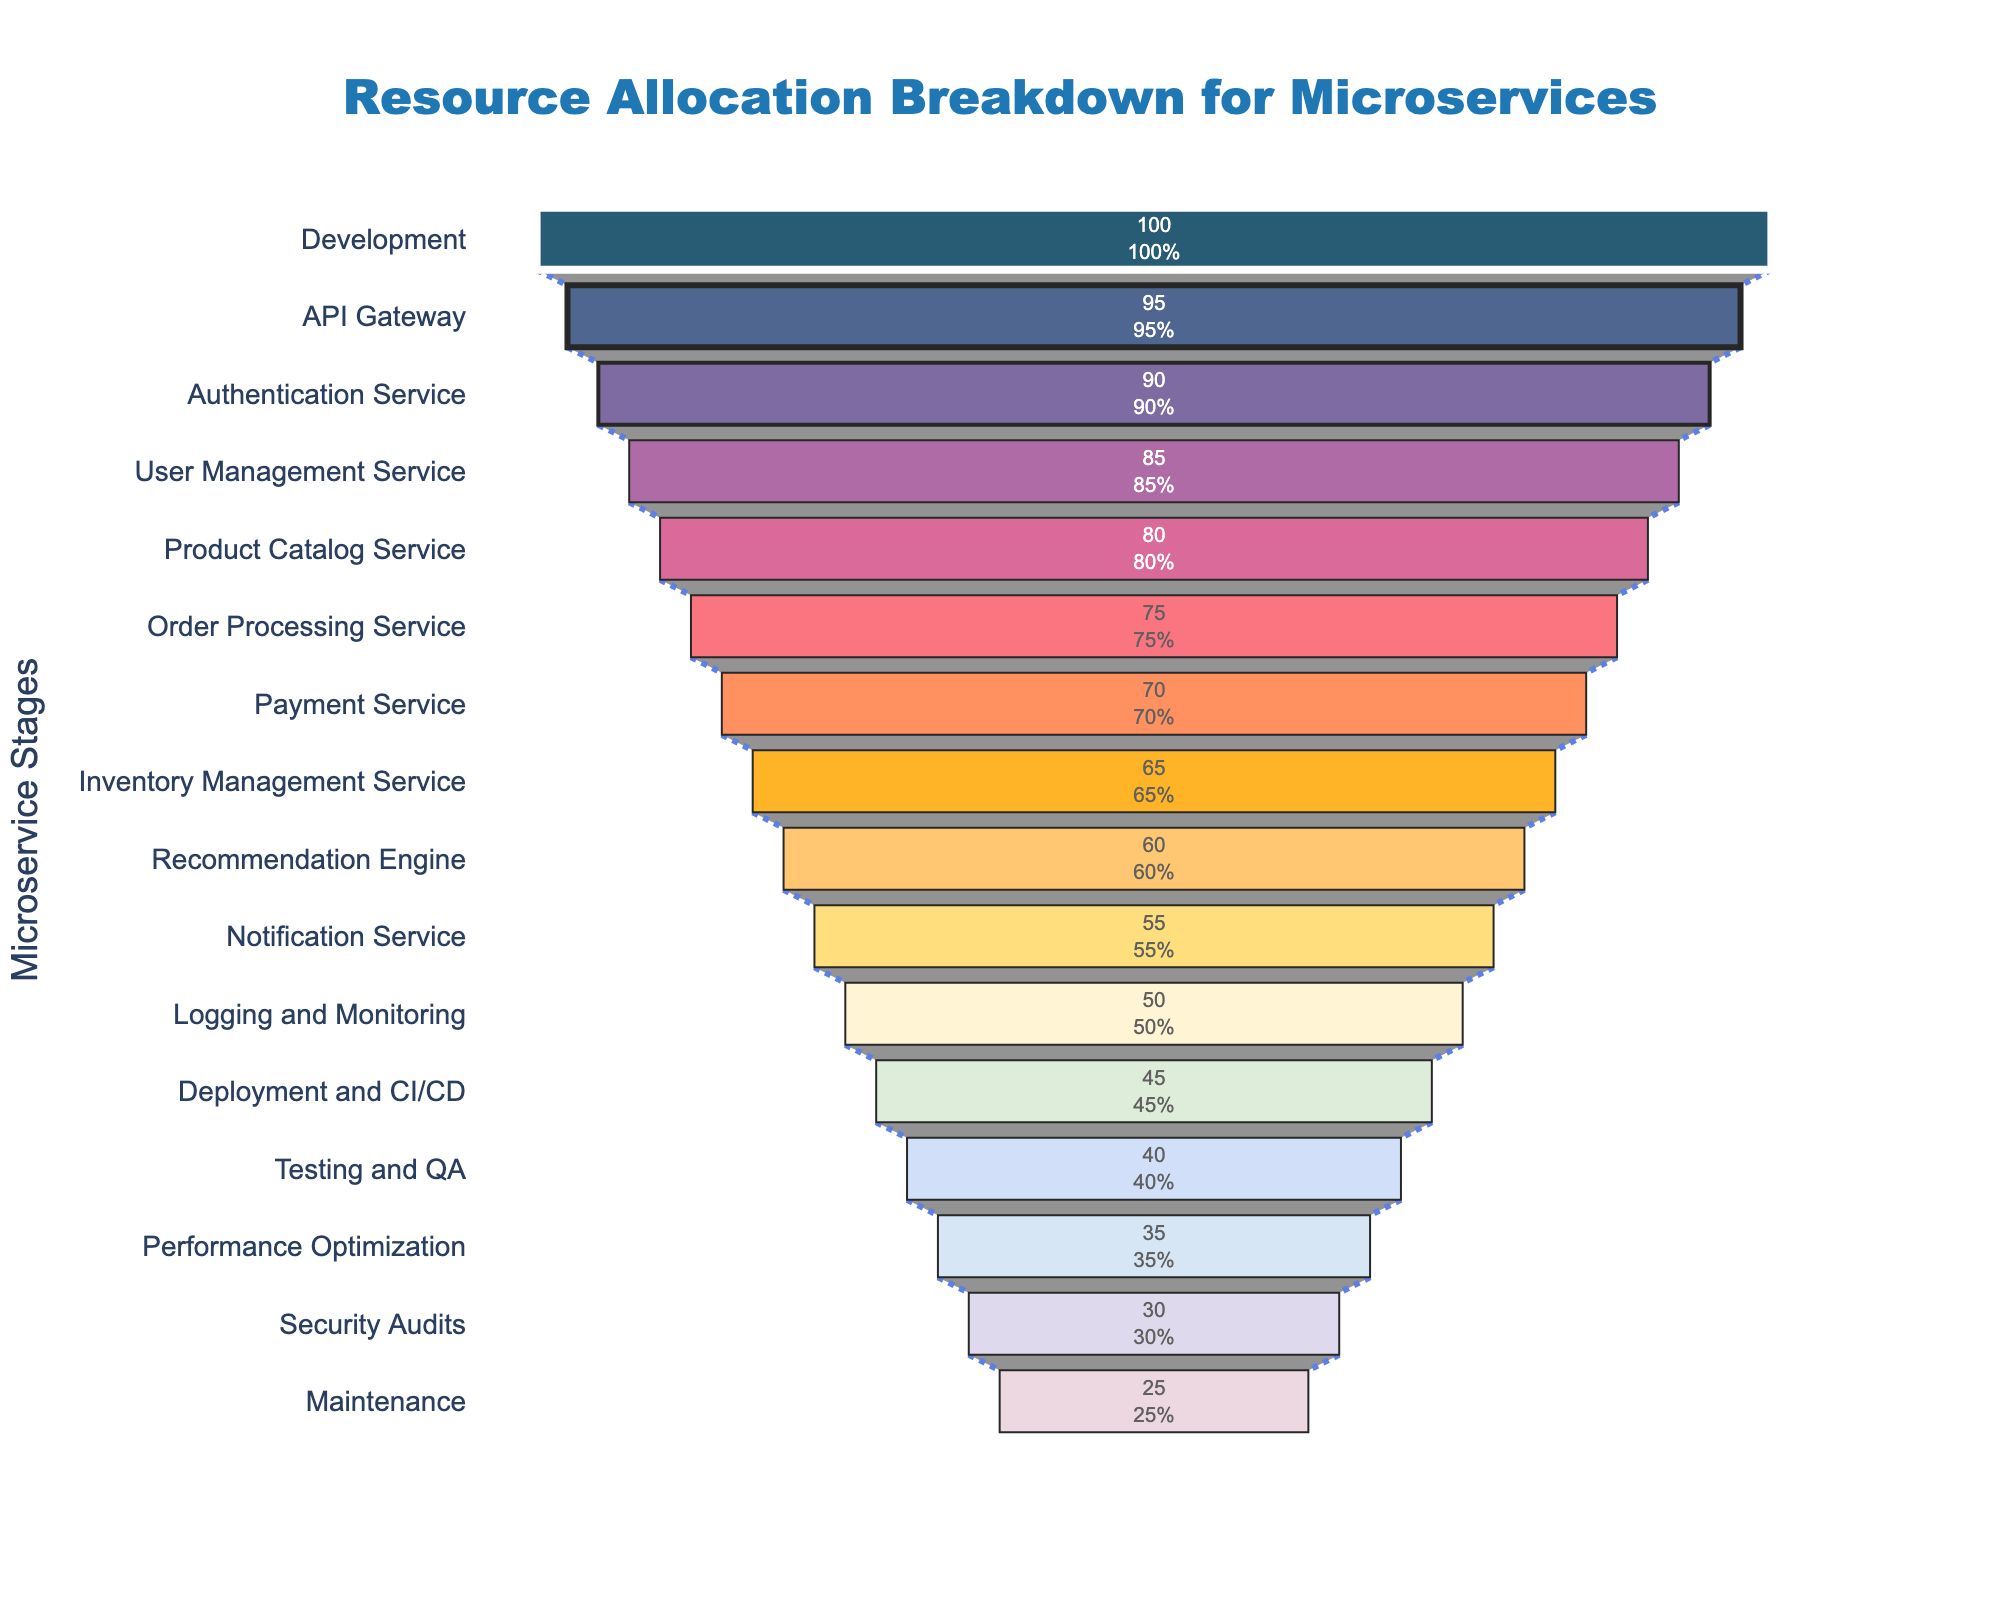What's the title of the figure? The title is displayed at the top of the figure within the layout. It is meant to summarize what the figure is about.
Answer: Resource Allocation Breakdown for Microservices How many stages are there in the funnel chart? The stages can be counted from the y-axis labels in the funnel chart dataset. Count these labels to determine the number of stages.
Answer: 16 Which stage has the highest resource allocation? By looking at the funnel chart, the highest resource allocation is at the top, where the percentage is largest.
Answer: Development What's the difference in resource allocation between the Order Processing Service and the Payment Service? Locate Order Processing Service (75%) and Payment Service (70%) on the funnel chart. Subtract the percentage of Payment Service from Order Processing Service.
Answer: 5% Comparing Deployment and CI/CD to Logging and Monitoring, which has a higher resource allocation? Locate both Deployment and CI/CD (45%) and Logging and Monitoring (50%) in the funnel chart, then compare their percentages.
Answer: Logging and Monitoring What is the resource allocation for the Notification Service? Find Notification Service on the funnel chart and read the corresponding percentage value.
Answer: 55% What is the average resource allocation of the stages from Testing and QA to Maintenance? The relevant stages are Testing and QA (40%), Performance Optimization (35%), Security Audits (30%), and Maintenance (25%). Calculate the sum (40 + 35 + 30 + 25) and then divide by the number of stages (4).
Answer: 32.5% Compare the resource allocations for the API Gateway and the Authentication Service. Which of these two has less resource allocation? Locate both API Gateway (95%) and Authentication Service (90%) in the funnel chart, then compare their percentages.
Answer: Authentication Service What's the total resource allocation for User Management Service, Product Catalog Service, and Order Processing Service? Sum the resource allocations for User Management Service (85%), Product Catalog Service (80%), and Order Processing Service (75%). Total = 85 + 80 + 75.
Answer: 240% How much resource allocation reduction is there from Performance Optimization to Security Audits? Locate Performance Optimization (35%) and Security Audits (30%) on the funnel chart. Subtract Security Audits from Performance Optimization.
Answer: 5% 